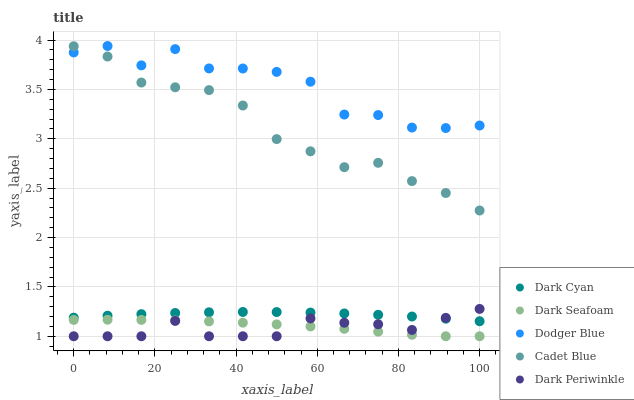Does Dark Periwinkle have the minimum area under the curve?
Answer yes or no. Yes. Does Dodger Blue have the maximum area under the curve?
Answer yes or no. Yes. Does Dark Seafoam have the minimum area under the curve?
Answer yes or no. No. Does Dark Seafoam have the maximum area under the curve?
Answer yes or no. No. Is Dark Cyan the smoothest?
Answer yes or no. Yes. Is Dodger Blue the roughest?
Answer yes or no. Yes. Is Dark Seafoam the smoothest?
Answer yes or no. No. Is Dark Seafoam the roughest?
Answer yes or no. No. Does Dark Seafoam have the lowest value?
Answer yes or no. Yes. Does Cadet Blue have the lowest value?
Answer yes or no. No. Does Dodger Blue have the highest value?
Answer yes or no. Yes. Does Cadet Blue have the highest value?
Answer yes or no. No. Is Dark Seafoam less than Dodger Blue?
Answer yes or no. Yes. Is Dodger Blue greater than Dark Periwinkle?
Answer yes or no. Yes. Does Dark Periwinkle intersect Dark Cyan?
Answer yes or no. Yes. Is Dark Periwinkle less than Dark Cyan?
Answer yes or no. No. Is Dark Periwinkle greater than Dark Cyan?
Answer yes or no. No. Does Dark Seafoam intersect Dodger Blue?
Answer yes or no. No. 